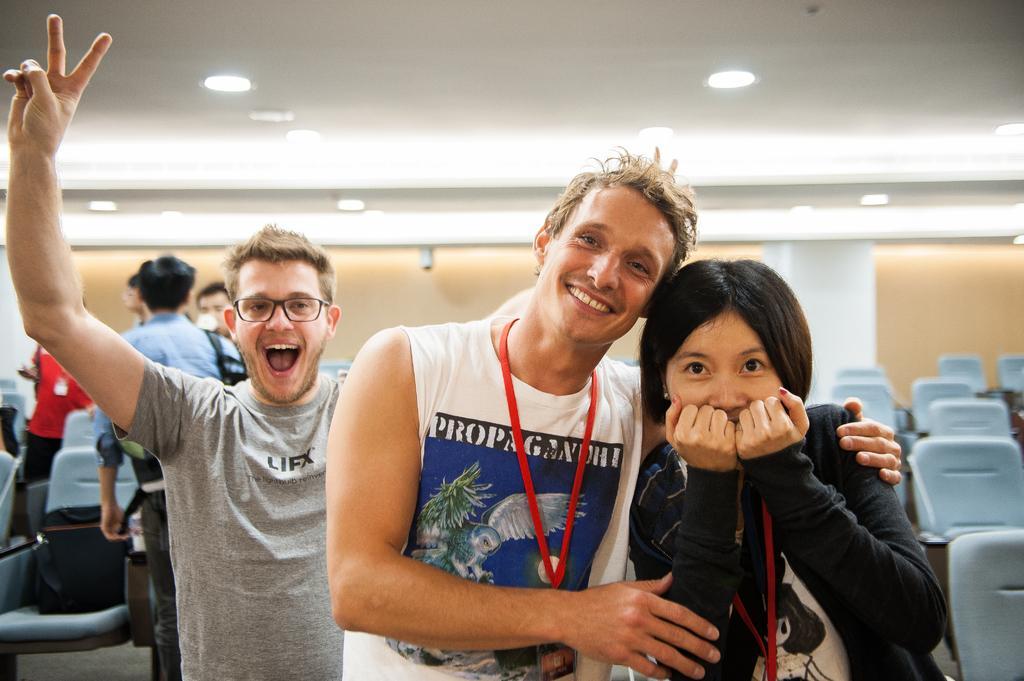Please provide a concise description of this image. In the image we can see there are people who are standing and wearing id cards in their hand. 